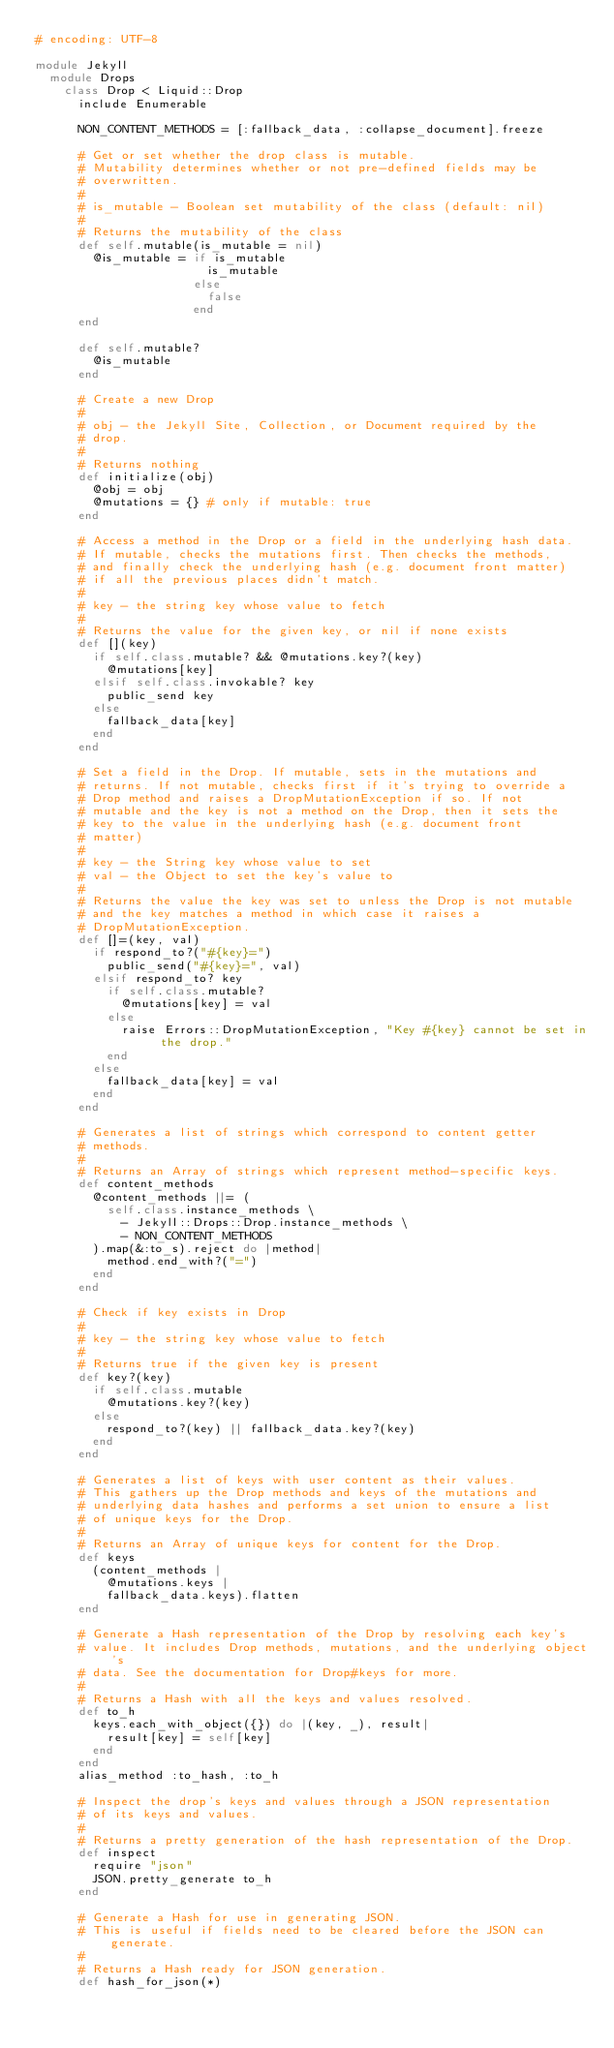Convert code to text. <code><loc_0><loc_0><loc_500><loc_500><_Ruby_># encoding: UTF-8

module Jekyll
  module Drops
    class Drop < Liquid::Drop
      include Enumerable

      NON_CONTENT_METHODS = [:fallback_data, :collapse_document].freeze

      # Get or set whether the drop class is mutable.
      # Mutability determines whether or not pre-defined fields may be
      # overwritten.
      #
      # is_mutable - Boolean set mutability of the class (default: nil)
      #
      # Returns the mutability of the class
      def self.mutable(is_mutable = nil)
        @is_mutable = if is_mutable
                        is_mutable
                      else
                        false
                      end
      end

      def self.mutable?
        @is_mutable
      end

      # Create a new Drop
      #
      # obj - the Jekyll Site, Collection, or Document required by the
      # drop.
      #
      # Returns nothing
      def initialize(obj)
        @obj = obj
        @mutations = {} # only if mutable: true
      end

      # Access a method in the Drop or a field in the underlying hash data.
      # If mutable, checks the mutations first. Then checks the methods,
      # and finally check the underlying hash (e.g. document front matter)
      # if all the previous places didn't match.
      #
      # key - the string key whose value to fetch
      #
      # Returns the value for the given key, or nil if none exists
      def [](key)
        if self.class.mutable? && @mutations.key?(key)
          @mutations[key]
        elsif self.class.invokable? key
          public_send key
        else
          fallback_data[key]
        end
      end

      # Set a field in the Drop. If mutable, sets in the mutations and
      # returns. If not mutable, checks first if it's trying to override a
      # Drop method and raises a DropMutationException if so. If not
      # mutable and the key is not a method on the Drop, then it sets the
      # key to the value in the underlying hash (e.g. document front
      # matter)
      #
      # key - the String key whose value to set
      # val - the Object to set the key's value to
      #
      # Returns the value the key was set to unless the Drop is not mutable
      # and the key matches a method in which case it raises a
      # DropMutationException.
      def []=(key, val)
        if respond_to?("#{key}=")
          public_send("#{key}=", val)
        elsif respond_to? key
          if self.class.mutable?
            @mutations[key] = val
          else
            raise Errors::DropMutationException, "Key #{key} cannot be set in the drop."
          end
        else
          fallback_data[key] = val
        end
      end

      # Generates a list of strings which correspond to content getter
      # methods.
      #
      # Returns an Array of strings which represent method-specific keys.
      def content_methods
        @content_methods ||= (
          self.class.instance_methods \
            - Jekyll::Drops::Drop.instance_methods \
            - NON_CONTENT_METHODS
        ).map(&:to_s).reject do |method|
          method.end_with?("=")
        end
      end

      # Check if key exists in Drop
      #
      # key - the string key whose value to fetch
      #
      # Returns true if the given key is present
      def key?(key)
        if self.class.mutable
          @mutations.key?(key)
        else
          respond_to?(key) || fallback_data.key?(key)
        end
      end

      # Generates a list of keys with user content as their values.
      # This gathers up the Drop methods and keys of the mutations and
      # underlying data hashes and performs a set union to ensure a list
      # of unique keys for the Drop.
      #
      # Returns an Array of unique keys for content for the Drop.
      def keys
        (content_methods |
          @mutations.keys |
          fallback_data.keys).flatten
      end

      # Generate a Hash representation of the Drop by resolving each key's
      # value. It includes Drop methods, mutations, and the underlying object's
      # data. See the documentation for Drop#keys for more.
      #
      # Returns a Hash with all the keys and values resolved.
      def to_h
        keys.each_with_object({}) do |(key, _), result|
          result[key] = self[key]
        end
      end
      alias_method :to_hash, :to_h

      # Inspect the drop's keys and values through a JSON representation
      # of its keys and values.
      #
      # Returns a pretty generation of the hash representation of the Drop.
      def inspect
        require "json"
        JSON.pretty_generate to_h
      end

      # Generate a Hash for use in generating JSON.
      # This is useful if fields need to be cleared before the JSON can generate.
      #
      # Returns a Hash ready for JSON generation.
      def hash_for_json(*)</code> 